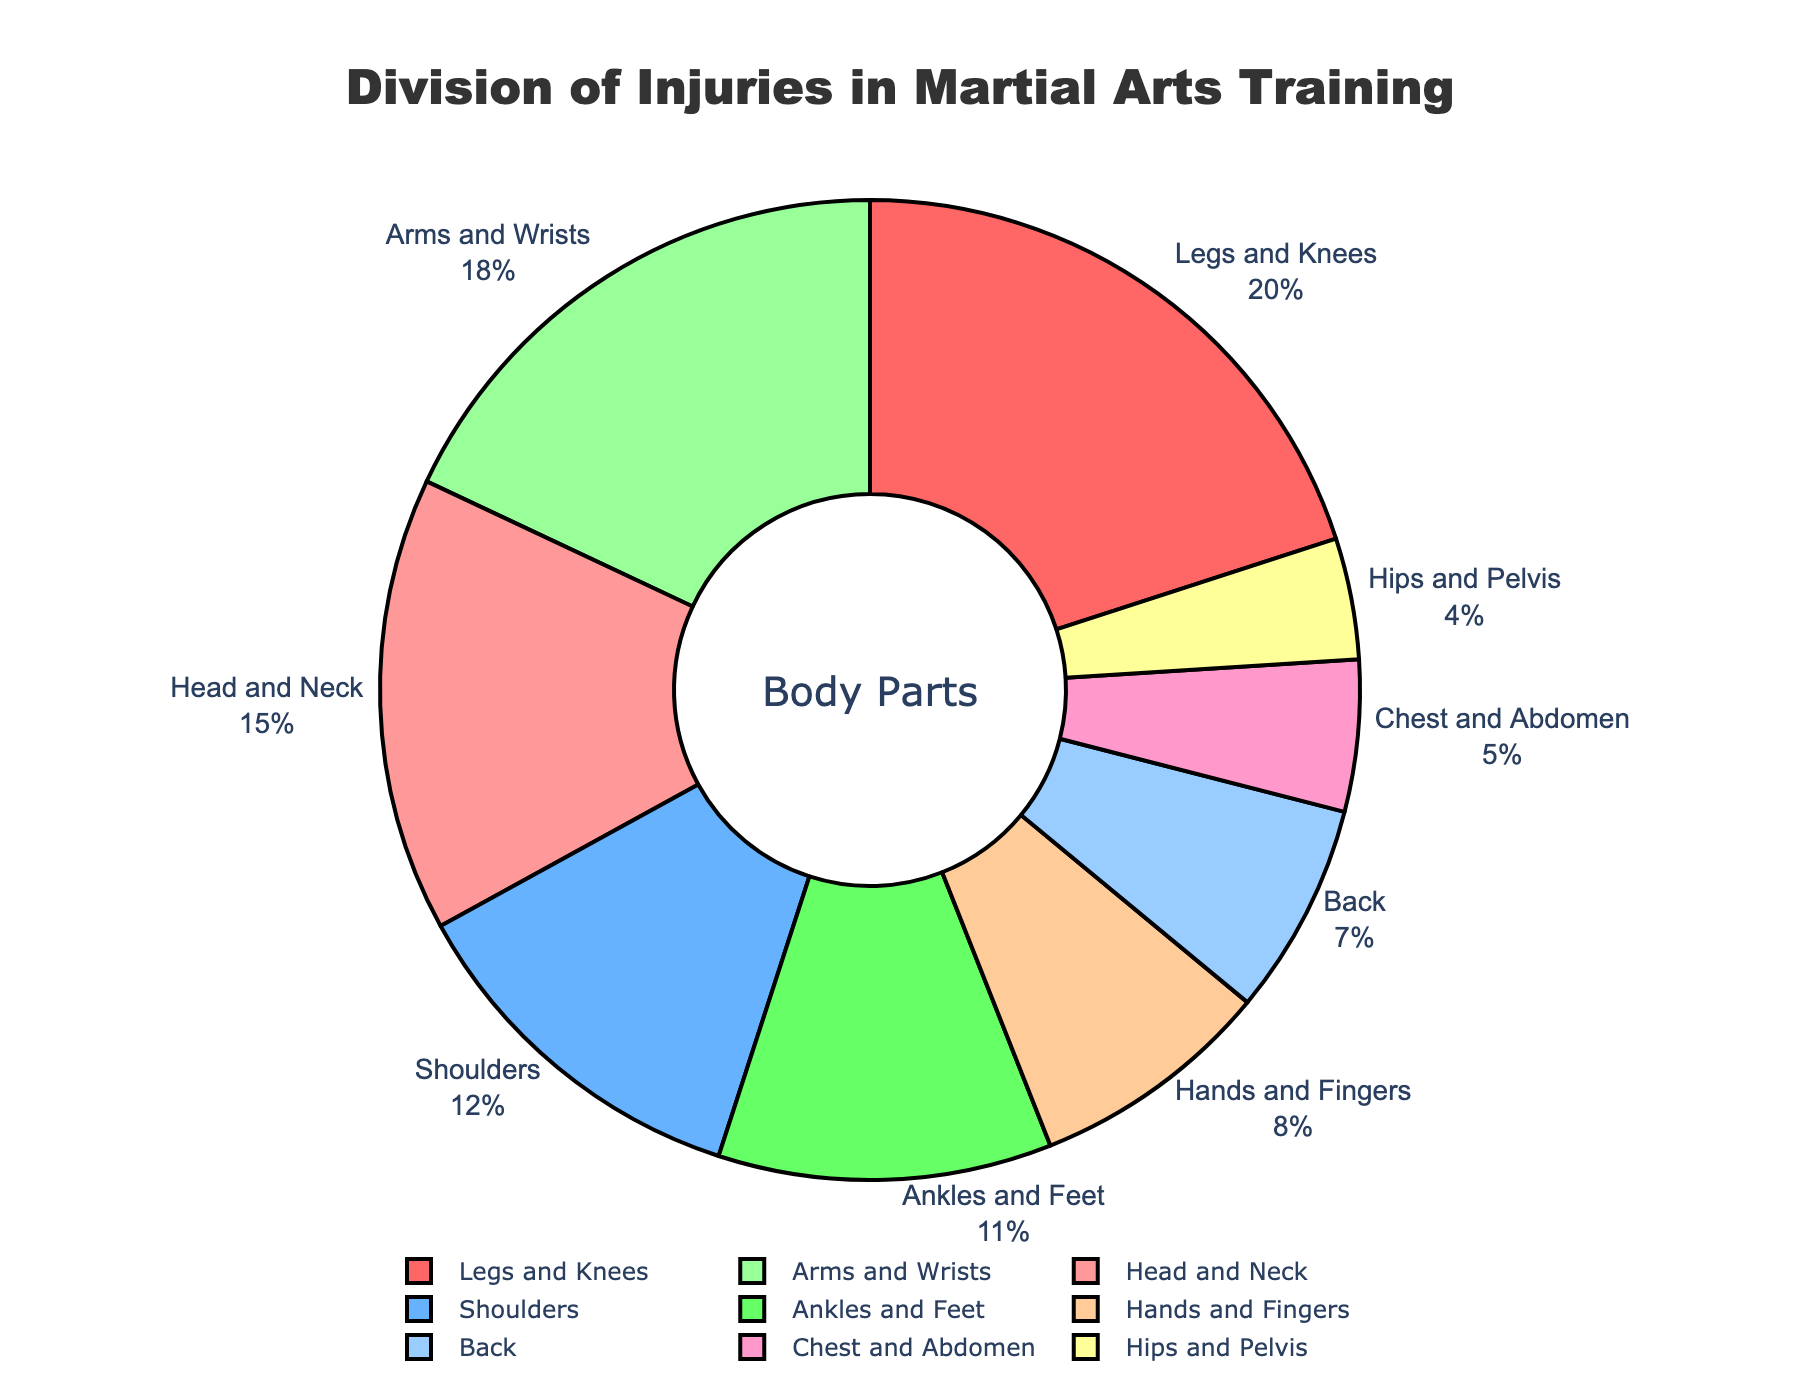Which body part has the highest percentage of injuries? Based on the figure, the section representing "Legs and Knees" is the largest.
Answer: Legs and Knees How does the percentage of injuries to the Head and Neck compare to the percentage of injuries to the Shoulders? The figure shows that the Head and Neck have a percentage of 15%, while the Shoulders have 12%. Thus, the Head and Neck have a higher percentage.
Answer: Head and Neck have a higher percentage What is the combined percentage of injuries to the Arms and Wrists, and Hands and Fingers? Adding the percentages for Arms and Wrists (18%) and Hands and Fingers (8%) gives 18% + 8% = 26%.
Answer: 26% Which body part has the smallest percentage of injuries? The segment representing Hips and Pelvis is the smallest on the figure.
Answer: Hips and Pelvis Are there more injuries to the Back or to the Ankles and Feet? The figure indicates that the Back has 7% of injuries while Ankles and Feet have 11%, so Ankles and Feet have more injuries.
Answer: Ankles and Feet What is the percentage difference between injuries to the Chest and Abdomen and to the Shoulders? Subtracting the percentage of Chest and Abdomen (5%) from Shoulders (12%) gives 12% - 5% = 7%.
Answer: 7% Is the percentage of injuries to the Legs and Knees more than double the percentage for the Hips and Pelvis? The figure shows that Legs and Knees are at 20% and Hips and Pelvis at 4%. Since 20% is more than double 4%, the answer is yes.
Answer: Yes What is the percentage of injuries to Upper body parts (Head and Neck, Shoulders, Arms and Wrists, Hands and Fingers)? Adding the percentages for Head and Neck (15%), Shoulders (12%), Arms and Wrists (18%), and Hands and Fingers (8%) results in 15% + 12% + 18% + 8% = 53%.
Answer: 53% Which group, Lower body (Hips and Pelvis, Legs and Knees, Ankles and Feet) or Upper body (Head and Neck, Shoulders, Arms and Wrists, Hands and Fingers), has a larger percentage of injuries? Lower body has 4% (Hips and Pelvis) + 20% (Legs and Knees) + 11% (Ankles and Feet) = 35%. Upper body has 53%. Therefore, Upper body has a larger percentage of injuries.
Answer: Upper body 